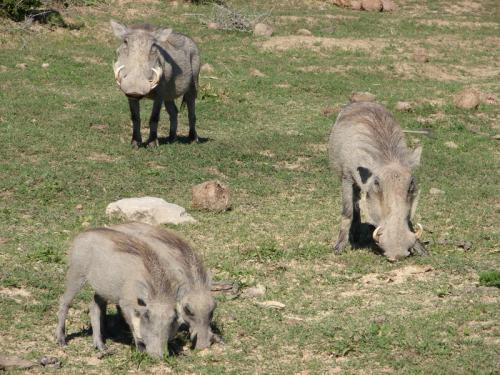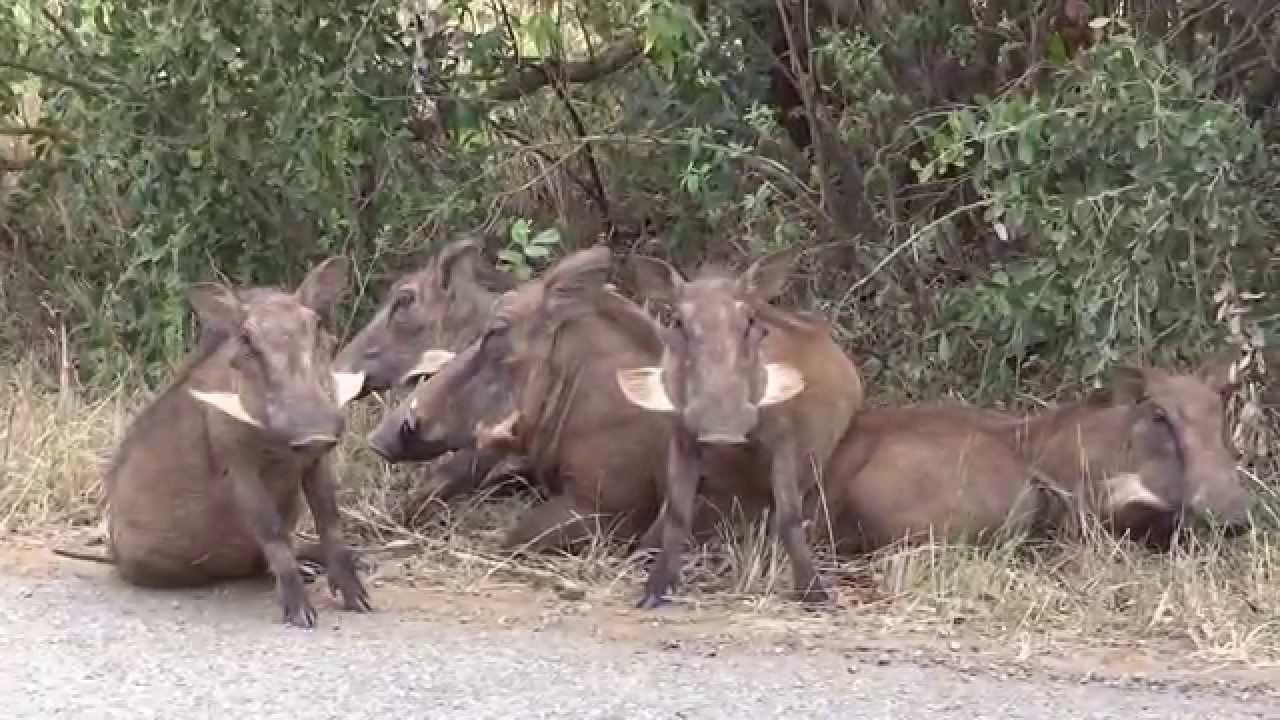The first image is the image on the left, the second image is the image on the right. For the images displayed, is the sentence "The image on the right has four or fewer warthogs." factually correct? Answer yes or no. No. The first image is the image on the left, the second image is the image on the right. Considering the images on both sides, is "One of the images contains exactly four warthogs." valid? Answer yes or no. Yes. 